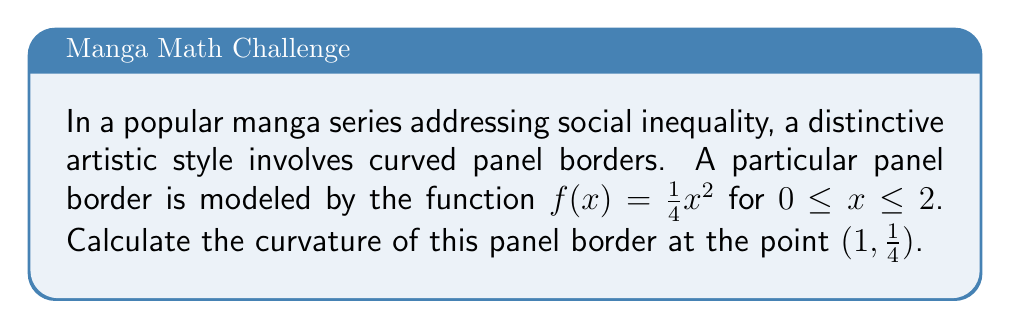Help me with this question. To calculate the curvature of the panel border, we'll follow these steps:

1) The formula for curvature $K$ of a function $y = f(x)$ at a point is:

   $$K = \frac{|f''(x)|}{(1 + [f'(x)]^2)^{3/2}}$$

2) First, let's find $f'(x)$ and $f''(x)$:
   
   $f'(x) = \frac{1}{2}x$
   $f''(x) = \frac{1}{2}$

3) At the point $(1, \frac{1}{4})$, $x = 1$. So:

   $f'(1) = \frac{1}{2}$
   $f''(1) = \frac{1}{2}$

4) Now, let's substitute these values into the curvature formula:

   $$K = \frac{|\frac{1}{2}|}{(1 + [\frac{1}{2}]^2)^{3/2}}$$

5) Simplify:
   
   $$K = \frac{\frac{1}{2}}{(1 + \frac{1}{4})^{3/2}} = \frac{\frac{1}{2}}{(\frac{5}{4})^{3/2}}$$

6) Evaluate:
   
   $$K = \frac{\frac{1}{2}}{(\frac{5}{4})^{3/2}} = \frac{\frac{1}{2}}{\frac{5\sqrt{5}}{8}} = \frac{4}{5\sqrt{5}}$$

Thus, the curvature of the panel border at the point $(1, \frac{1}{4})$ is $\frac{4}{5\sqrt{5}}$.
Answer: $\frac{4}{5\sqrt{5}}$ 